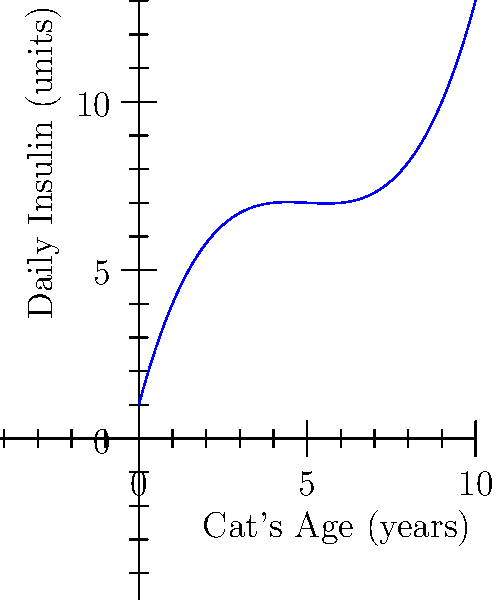The graph shows the relationship between a cat's age and its daily insulin requirements. Point A represents a 2-year-old cat, and point B represents a 6-year-old cat. What is the approximate difference in daily insulin units between these two cats? To find the difference in daily insulin units between the 2-year-old cat (point A) and the 6-year-old cat (point B), we need to:

1. Estimate the y-value (insulin units) for point A (2-year-old cat):
   From the graph, we can see that point A is approximately at 6.5 units.

2. Estimate the y-value (insulin units) for point B (6-year-old cat):
   From the graph, we can see that point B is approximately at 4 units.

3. Calculate the difference:
   Difference = Insulin units for 2-year-old cat - Insulin units for 6-year-old cat
   $$ 6.5 - 4 = 2.5 $$

Therefore, the approximate difference in daily insulin units between the 2-year-old cat and the 6-year-old cat is 2.5 units.
Answer: 2.5 units 